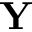Convert formula to latex. <formula><loc_0><loc_0><loc_500><loc_500>Y</formula> 